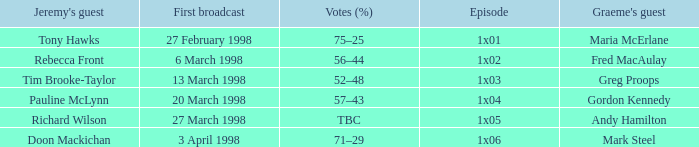What is Graeme's Guest, when Episode is "1x03"? Greg Proops. Would you mind parsing the complete table? {'header': ["Jeremy's guest", 'First broadcast', 'Votes (%)', 'Episode', "Graeme's guest"], 'rows': [['Tony Hawks', '27 February 1998', '75–25', '1x01', 'Maria McErlane'], ['Rebecca Front', '6 March 1998', '56–44', '1x02', 'Fred MacAulay'], ['Tim Brooke-Taylor', '13 March 1998', '52–48', '1x03', 'Greg Proops'], ['Pauline McLynn', '20 March 1998', '57–43', '1x04', 'Gordon Kennedy'], ['Richard Wilson', '27 March 1998', 'TBC', '1x05', 'Andy Hamilton'], ['Doon Mackichan', '3 April 1998', '71–29', '1x06', 'Mark Steel']]} 